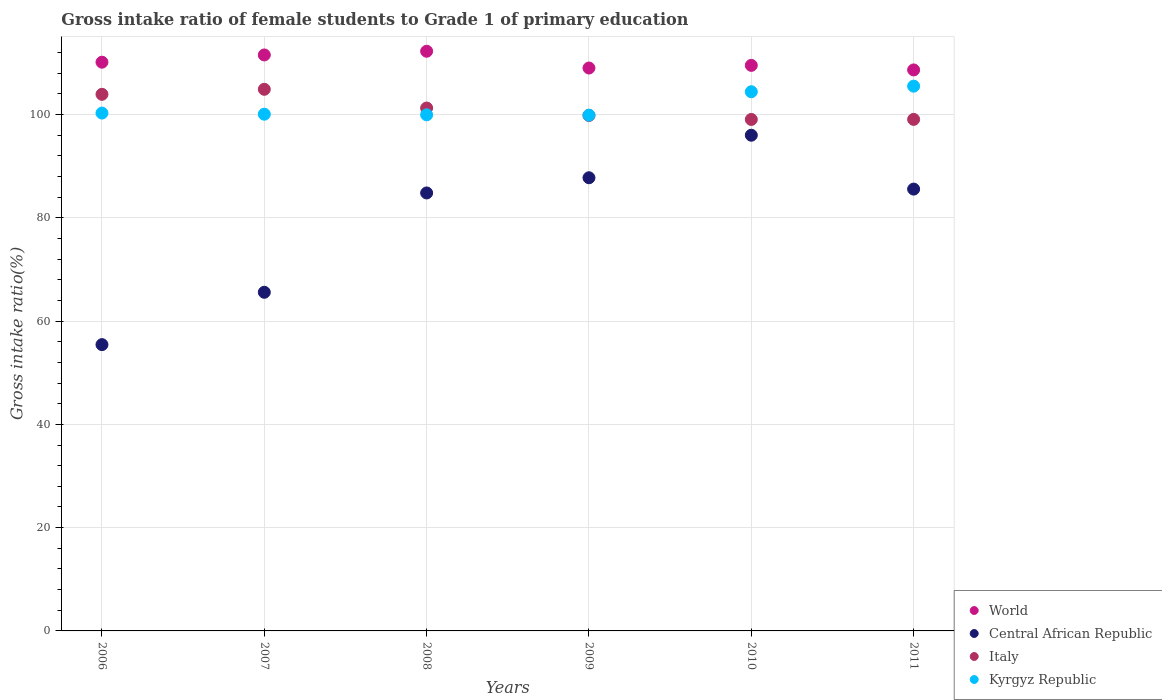How many different coloured dotlines are there?
Make the answer very short. 4. What is the gross intake ratio in Central African Republic in 2011?
Offer a terse response. 85.56. Across all years, what is the maximum gross intake ratio in World?
Provide a short and direct response. 112.26. Across all years, what is the minimum gross intake ratio in Italy?
Your answer should be compact. 99.05. In which year was the gross intake ratio in Central African Republic maximum?
Offer a very short reply. 2010. What is the total gross intake ratio in Italy in the graph?
Provide a succinct answer. 608. What is the difference between the gross intake ratio in Kyrgyz Republic in 2010 and that in 2011?
Keep it short and to the point. -1.08. What is the difference between the gross intake ratio in Central African Republic in 2006 and the gross intake ratio in World in 2010?
Offer a terse response. -54.08. What is the average gross intake ratio in World per year?
Your answer should be very brief. 110.18. In the year 2009, what is the difference between the gross intake ratio in Central African Republic and gross intake ratio in World?
Offer a very short reply. -21.25. What is the ratio of the gross intake ratio in Central African Republic in 2009 to that in 2010?
Offer a terse response. 0.91. Is the gross intake ratio in Central African Republic in 2007 less than that in 2009?
Give a very brief answer. Yes. Is the difference between the gross intake ratio in Central African Republic in 2006 and 2008 greater than the difference between the gross intake ratio in World in 2006 and 2008?
Make the answer very short. No. What is the difference between the highest and the second highest gross intake ratio in Kyrgyz Republic?
Make the answer very short. 1.08. What is the difference between the highest and the lowest gross intake ratio in Italy?
Make the answer very short. 5.84. Is it the case that in every year, the sum of the gross intake ratio in Italy and gross intake ratio in World  is greater than the sum of gross intake ratio in Kyrgyz Republic and gross intake ratio in Central African Republic?
Make the answer very short. No. Is it the case that in every year, the sum of the gross intake ratio in Kyrgyz Republic and gross intake ratio in Italy  is greater than the gross intake ratio in World?
Offer a terse response. Yes. Is the gross intake ratio in Kyrgyz Republic strictly greater than the gross intake ratio in World over the years?
Your answer should be very brief. No. How many dotlines are there?
Ensure brevity in your answer.  4. What is the difference between two consecutive major ticks on the Y-axis?
Your answer should be very brief. 20. Are the values on the major ticks of Y-axis written in scientific E-notation?
Offer a terse response. No. Does the graph contain any zero values?
Offer a terse response. No. Where does the legend appear in the graph?
Your answer should be compact. Bottom right. How are the legend labels stacked?
Your response must be concise. Vertical. What is the title of the graph?
Keep it short and to the point. Gross intake ratio of female students to Grade 1 of primary education. Does "Singapore" appear as one of the legend labels in the graph?
Ensure brevity in your answer.  No. What is the label or title of the X-axis?
Offer a terse response. Years. What is the label or title of the Y-axis?
Offer a very short reply. Gross intake ratio(%). What is the Gross intake ratio(%) of World in 2006?
Your answer should be compact. 110.14. What is the Gross intake ratio(%) of Central African Republic in 2006?
Make the answer very short. 55.44. What is the Gross intake ratio(%) in Italy in 2006?
Give a very brief answer. 103.92. What is the Gross intake ratio(%) of Kyrgyz Republic in 2006?
Provide a succinct answer. 100.28. What is the Gross intake ratio(%) in World in 2007?
Provide a short and direct response. 111.54. What is the Gross intake ratio(%) in Central African Republic in 2007?
Offer a terse response. 65.58. What is the Gross intake ratio(%) of Italy in 2007?
Your answer should be very brief. 104.89. What is the Gross intake ratio(%) of Kyrgyz Republic in 2007?
Offer a very short reply. 100.07. What is the Gross intake ratio(%) in World in 2008?
Provide a succinct answer. 112.26. What is the Gross intake ratio(%) of Central African Republic in 2008?
Provide a succinct answer. 84.81. What is the Gross intake ratio(%) of Italy in 2008?
Keep it short and to the point. 101.26. What is the Gross intake ratio(%) of Kyrgyz Republic in 2008?
Ensure brevity in your answer.  99.95. What is the Gross intake ratio(%) of World in 2009?
Keep it short and to the point. 109.01. What is the Gross intake ratio(%) of Central African Republic in 2009?
Offer a terse response. 87.76. What is the Gross intake ratio(%) of Italy in 2009?
Offer a terse response. 99.83. What is the Gross intake ratio(%) in Kyrgyz Republic in 2009?
Give a very brief answer. 99.88. What is the Gross intake ratio(%) of World in 2010?
Give a very brief answer. 109.52. What is the Gross intake ratio(%) in Central African Republic in 2010?
Keep it short and to the point. 95.99. What is the Gross intake ratio(%) of Italy in 2010?
Provide a short and direct response. 99.05. What is the Gross intake ratio(%) in Kyrgyz Republic in 2010?
Offer a terse response. 104.41. What is the Gross intake ratio(%) of World in 2011?
Make the answer very short. 108.64. What is the Gross intake ratio(%) in Central African Republic in 2011?
Offer a very short reply. 85.56. What is the Gross intake ratio(%) of Italy in 2011?
Provide a succinct answer. 99.06. What is the Gross intake ratio(%) in Kyrgyz Republic in 2011?
Your response must be concise. 105.5. Across all years, what is the maximum Gross intake ratio(%) in World?
Your answer should be very brief. 112.26. Across all years, what is the maximum Gross intake ratio(%) in Central African Republic?
Your answer should be compact. 95.99. Across all years, what is the maximum Gross intake ratio(%) of Italy?
Provide a short and direct response. 104.89. Across all years, what is the maximum Gross intake ratio(%) in Kyrgyz Republic?
Offer a very short reply. 105.5. Across all years, what is the minimum Gross intake ratio(%) in World?
Your response must be concise. 108.64. Across all years, what is the minimum Gross intake ratio(%) in Central African Republic?
Your answer should be very brief. 55.44. Across all years, what is the minimum Gross intake ratio(%) of Italy?
Make the answer very short. 99.05. Across all years, what is the minimum Gross intake ratio(%) of Kyrgyz Republic?
Provide a succinct answer. 99.88. What is the total Gross intake ratio(%) of World in the graph?
Your answer should be very brief. 661.1. What is the total Gross intake ratio(%) of Central African Republic in the graph?
Offer a very short reply. 475.15. What is the total Gross intake ratio(%) in Italy in the graph?
Offer a terse response. 608. What is the total Gross intake ratio(%) of Kyrgyz Republic in the graph?
Your answer should be very brief. 610.09. What is the difference between the Gross intake ratio(%) in World in 2006 and that in 2007?
Ensure brevity in your answer.  -1.4. What is the difference between the Gross intake ratio(%) of Central African Republic in 2006 and that in 2007?
Make the answer very short. -10.14. What is the difference between the Gross intake ratio(%) of Italy in 2006 and that in 2007?
Make the answer very short. -0.97. What is the difference between the Gross intake ratio(%) in Kyrgyz Republic in 2006 and that in 2007?
Your answer should be compact. 0.22. What is the difference between the Gross intake ratio(%) in World in 2006 and that in 2008?
Ensure brevity in your answer.  -2.12. What is the difference between the Gross intake ratio(%) of Central African Republic in 2006 and that in 2008?
Keep it short and to the point. -29.37. What is the difference between the Gross intake ratio(%) of Italy in 2006 and that in 2008?
Offer a very short reply. 2.65. What is the difference between the Gross intake ratio(%) of Kyrgyz Republic in 2006 and that in 2008?
Give a very brief answer. 0.34. What is the difference between the Gross intake ratio(%) in World in 2006 and that in 2009?
Offer a very short reply. 1.13. What is the difference between the Gross intake ratio(%) of Central African Republic in 2006 and that in 2009?
Your answer should be very brief. -32.31. What is the difference between the Gross intake ratio(%) of Italy in 2006 and that in 2009?
Your answer should be very brief. 4.09. What is the difference between the Gross intake ratio(%) in Kyrgyz Republic in 2006 and that in 2009?
Ensure brevity in your answer.  0.4. What is the difference between the Gross intake ratio(%) in World in 2006 and that in 2010?
Keep it short and to the point. 0.62. What is the difference between the Gross intake ratio(%) in Central African Republic in 2006 and that in 2010?
Offer a terse response. -40.55. What is the difference between the Gross intake ratio(%) in Italy in 2006 and that in 2010?
Your response must be concise. 4.87. What is the difference between the Gross intake ratio(%) in Kyrgyz Republic in 2006 and that in 2010?
Offer a very short reply. -4.13. What is the difference between the Gross intake ratio(%) in World in 2006 and that in 2011?
Offer a very short reply. 1.5. What is the difference between the Gross intake ratio(%) in Central African Republic in 2006 and that in 2011?
Your answer should be compact. -30.12. What is the difference between the Gross intake ratio(%) in Italy in 2006 and that in 2011?
Provide a succinct answer. 4.85. What is the difference between the Gross intake ratio(%) of Kyrgyz Republic in 2006 and that in 2011?
Ensure brevity in your answer.  -5.21. What is the difference between the Gross intake ratio(%) in World in 2007 and that in 2008?
Make the answer very short. -0.72. What is the difference between the Gross intake ratio(%) in Central African Republic in 2007 and that in 2008?
Give a very brief answer. -19.23. What is the difference between the Gross intake ratio(%) in Italy in 2007 and that in 2008?
Your answer should be compact. 3.63. What is the difference between the Gross intake ratio(%) of Kyrgyz Republic in 2007 and that in 2008?
Offer a very short reply. 0.12. What is the difference between the Gross intake ratio(%) of World in 2007 and that in 2009?
Provide a succinct answer. 2.53. What is the difference between the Gross intake ratio(%) of Central African Republic in 2007 and that in 2009?
Make the answer very short. -22.18. What is the difference between the Gross intake ratio(%) of Italy in 2007 and that in 2009?
Your answer should be compact. 5.06. What is the difference between the Gross intake ratio(%) of Kyrgyz Republic in 2007 and that in 2009?
Offer a terse response. 0.18. What is the difference between the Gross intake ratio(%) in World in 2007 and that in 2010?
Keep it short and to the point. 2.02. What is the difference between the Gross intake ratio(%) of Central African Republic in 2007 and that in 2010?
Ensure brevity in your answer.  -30.41. What is the difference between the Gross intake ratio(%) in Italy in 2007 and that in 2010?
Your answer should be very brief. 5.84. What is the difference between the Gross intake ratio(%) in Kyrgyz Republic in 2007 and that in 2010?
Give a very brief answer. -4.35. What is the difference between the Gross intake ratio(%) in World in 2007 and that in 2011?
Your response must be concise. 2.9. What is the difference between the Gross intake ratio(%) of Central African Republic in 2007 and that in 2011?
Your answer should be very brief. -19.98. What is the difference between the Gross intake ratio(%) of Italy in 2007 and that in 2011?
Ensure brevity in your answer.  5.83. What is the difference between the Gross intake ratio(%) of Kyrgyz Republic in 2007 and that in 2011?
Offer a very short reply. -5.43. What is the difference between the Gross intake ratio(%) of World in 2008 and that in 2009?
Keep it short and to the point. 3.25. What is the difference between the Gross intake ratio(%) in Central African Republic in 2008 and that in 2009?
Offer a very short reply. -2.94. What is the difference between the Gross intake ratio(%) of Italy in 2008 and that in 2009?
Keep it short and to the point. 1.44. What is the difference between the Gross intake ratio(%) in Kyrgyz Republic in 2008 and that in 2009?
Give a very brief answer. 0.07. What is the difference between the Gross intake ratio(%) of World in 2008 and that in 2010?
Ensure brevity in your answer.  2.74. What is the difference between the Gross intake ratio(%) in Central African Republic in 2008 and that in 2010?
Give a very brief answer. -11.18. What is the difference between the Gross intake ratio(%) of Italy in 2008 and that in 2010?
Provide a short and direct response. 2.21. What is the difference between the Gross intake ratio(%) in Kyrgyz Republic in 2008 and that in 2010?
Provide a short and direct response. -4.47. What is the difference between the Gross intake ratio(%) of World in 2008 and that in 2011?
Offer a very short reply. 3.62. What is the difference between the Gross intake ratio(%) in Central African Republic in 2008 and that in 2011?
Keep it short and to the point. -0.75. What is the difference between the Gross intake ratio(%) of Italy in 2008 and that in 2011?
Provide a succinct answer. 2.2. What is the difference between the Gross intake ratio(%) in Kyrgyz Republic in 2008 and that in 2011?
Provide a succinct answer. -5.55. What is the difference between the Gross intake ratio(%) in World in 2009 and that in 2010?
Provide a short and direct response. -0.51. What is the difference between the Gross intake ratio(%) in Central African Republic in 2009 and that in 2010?
Provide a succinct answer. -8.24. What is the difference between the Gross intake ratio(%) of Italy in 2009 and that in 2010?
Give a very brief answer. 0.78. What is the difference between the Gross intake ratio(%) in Kyrgyz Republic in 2009 and that in 2010?
Ensure brevity in your answer.  -4.53. What is the difference between the Gross intake ratio(%) in World in 2009 and that in 2011?
Offer a terse response. 0.37. What is the difference between the Gross intake ratio(%) of Central African Republic in 2009 and that in 2011?
Provide a succinct answer. 2.2. What is the difference between the Gross intake ratio(%) of Italy in 2009 and that in 2011?
Offer a very short reply. 0.77. What is the difference between the Gross intake ratio(%) of Kyrgyz Republic in 2009 and that in 2011?
Give a very brief answer. -5.62. What is the difference between the Gross intake ratio(%) in World in 2010 and that in 2011?
Offer a terse response. 0.88. What is the difference between the Gross intake ratio(%) in Central African Republic in 2010 and that in 2011?
Your response must be concise. 10.43. What is the difference between the Gross intake ratio(%) of Italy in 2010 and that in 2011?
Make the answer very short. -0.01. What is the difference between the Gross intake ratio(%) in Kyrgyz Republic in 2010 and that in 2011?
Ensure brevity in your answer.  -1.08. What is the difference between the Gross intake ratio(%) in World in 2006 and the Gross intake ratio(%) in Central African Republic in 2007?
Provide a succinct answer. 44.56. What is the difference between the Gross intake ratio(%) of World in 2006 and the Gross intake ratio(%) of Italy in 2007?
Your response must be concise. 5.25. What is the difference between the Gross intake ratio(%) of World in 2006 and the Gross intake ratio(%) of Kyrgyz Republic in 2007?
Keep it short and to the point. 10.07. What is the difference between the Gross intake ratio(%) of Central African Republic in 2006 and the Gross intake ratio(%) of Italy in 2007?
Offer a terse response. -49.45. What is the difference between the Gross intake ratio(%) of Central African Republic in 2006 and the Gross intake ratio(%) of Kyrgyz Republic in 2007?
Provide a succinct answer. -44.62. What is the difference between the Gross intake ratio(%) of Italy in 2006 and the Gross intake ratio(%) of Kyrgyz Republic in 2007?
Make the answer very short. 3.85. What is the difference between the Gross intake ratio(%) of World in 2006 and the Gross intake ratio(%) of Central African Republic in 2008?
Provide a succinct answer. 25.32. What is the difference between the Gross intake ratio(%) in World in 2006 and the Gross intake ratio(%) in Italy in 2008?
Your answer should be very brief. 8.87. What is the difference between the Gross intake ratio(%) in World in 2006 and the Gross intake ratio(%) in Kyrgyz Republic in 2008?
Your answer should be compact. 10.19. What is the difference between the Gross intake ratio(%) of Central African Republic in 2006 and the Gross intake ratio(%) of Italy in 2008?
Ensure brevity in your answer.  -45.82. What is the difference between the Gross intake ratio(%) of Central African Republic in 2006 and the Gross intake ratio(%) of Kyrgyz Republic in 2008?
Your answer should be very brief. -44.51. What is the difference between the Gross intake ratio(%) of Italy in 2006 and the Gross intake ratio(%) of Kyrgyz Republic in 2008?
Your response must be concise. 3.97. What is the difference between the Gross intake ratio(%) in World in 2006 and the Gross intake ratio(%) in Central African Republic in 2009?
Your answer should be compact. 22.38. What is the difference between the Gross intake ratio(%) in World in 2006 and the Gross intake ratio(%) in Italy in 2009?
Your answer should be very brief. 10.31. What is the difference between the Gross intake ratio(%) of World in 2006 and the Gross intake ratio(%) of Kyrgyz Republic in 2009?
Ensure brevity in your answer.  10.25. What is the difference between the Gross intake ratio(%) in Central African Republic in 2006 and the Gross intake ratio(%) in Italy in 2009?
Keep it short and to the point. -44.38. What is the difference between the Gross intake ratio(%) of Central African Republic in 2006 and the Gross intake ratio(%) of Kyrgyz Republic in 2009?
Your answer should be very brief. -44.44. What is the difference between the Gross intake ratio(%) in Italy in 2006 and the Gross intake ratio(%) in Kyrgyz Republic in 2009?
Provide a short and direct response. 4.03. What is the difference between the Gross intake ratio(%) of World in 2006 and the Gross intake ratio(%) of Central African Republic in 2010?
Offer a terse response. 14.14. What is the difference between the Gross intake ratio(%) in World in 2006 and the Gross intake ratio(%) in Italy in 2010?
Give a very brief answer. 11.09. What is the difference between the Gross intake ratio(%) in World in 2006 and the Gross intake ratio(%) in Kyrgyz Republic in 2010?
Offer a very short reply. 5.72. What is the difference between the Gross intake ratio(%) of Central African Republic in 2006 and the Gross intake ratio(%) of Italy in 2010?
Provide a succinct answer. -43.61. What is the difference between the Gross intake ratio(%) in Central African Republic in 2006 and the Gross intake ratio(%) in Kyrgyz Republic in 2010?
Offer a terse response. -48.97. What is the difference between the Gross intake ratio(%) of Italy in 2006 and the Gross intake ratio(%) of Kyrgyz Republic in 2010?
Keep it short and to the point. -0.5. What is the difference between the Gross intake ratio(%) in World in 2006 and the Gross intake ratio(%) in Central African Republic in 2011?
Your answer should be compact. 24.58. What is the difference between the Gross intake ratio(%) of World in 2006 and the Gross intake ratio(%) of Italy in 2011?
Your answer should be very brief. 11.08. What is the difference between the Gross intake ratio(%) of World in 2006 and the Gross intake ratio(%) of Kyrgyz Republic in 2011?
Offer a very short reply. 4.64. What is the difference between the Gross intake ratio(%) of Central African Republic in 2006 and the Gross intake ratio(%) of Italy in 2011?
Keep it short and to the point. -43.62. What is the difference between the Gross intake ratio(%) in Central African Republic in 2006 and the Gross intake ratio(%) in Kyrgyz Republic in 2011?
Ensure brevity in your answer.  -50.06. What is the difference between the Gross intake ratio(%) of Italy in 2006 and the Gross intake ratio(%) of Kyrgyz Republic in 2011?
Give a very brief answer. -1.58. What is the difference between the Gross intake ratio(%) of World in 2007 and the Gross intake ratio(%) of Central African Republic in 2008?
Your answer should be very brief. 26.73. What is the difference between the Gross intake ratio(%) in World in 2007 and the Gross intake ratio(%) in Italy in 2008?
Make the answer very short. 10.28. What is the difference between the Gross intake ratio(%) of World in 2007 and the Gross intake ratio(%) of Kyrgyz Republic in 2008?
Keep it short and to the point. 11.59. What is the difference between the Gross intake ratio(%) in Central African Republic in 2007 and the Gross intake ratio(%) in Italy in 2008?
Offer a terse response. -35.68. What is the difference between the Gross intake ratio(%) of Central African Republic in 2007 and the Gross intake ratio(%) of Kyrgyz Republic in 2008?
Give a very brief answer. -34.37. What is the difference between the Gross intake ratio(%) in Italy in 2007 and the Gross intake ratio(%) in Kyrgyz Republic in 2008?
Ensure brevity in your answer.  4.94. What is the difference between the Gross intake ratio(%) of World in 2007 and the Gross intake ratio(%) of Central African Republic in 2009?
Provide a short and direct response. 23.78. What is the difference between the Gross intake ratio(%) in World in 2007 and the Gross intake ratio(%) in Italy in 2009?
Your response must be concise. 11.71. What is the difference between the Gross intake ratio(%) in World in 2007 and the Gross intake ratio(%) in Kyrgyz Republic in 2009?
Ensure brevity in your answer.  11.66. What is the difference between the Gross intake ratio(%) in Central African Republic in 2007 and the Gross intake ratio(%) in Italy in 2009?
Provide a succinct answer. -34.25. What is the difference between the Gross intake ratio(%) of Central African Republic in 2007 and the Gross intake ratio(%) of Kyrgyz Republic in 2009?
Keep it short and to the point. -34.3. What is the difference between the Gross intake ratio(%) in Italy in 2007 and the Gross intake ratio(%) in Kyrgyz Republic in 2009?
Your answer should be compact. 5.01. What is the difference between the Gross intake ratio(%) of World in 2007 and the Gross intake ratio(%) of Central African Republic in 2010?
Give a very brief answer. 15.55. What is the difference between the Gross intake ratio(%) of World in 2007 and the Gross intake ratio(%) of Italy in 2010?
Give a very brief answer. 12.49. What is the difference between the Gross intake ratio(%) of World in 2007 and the Gross intake ratio(%) of Kyrgyz Republic in 2010?
Provide a succinct answer. 7.13. What is the difference between the Gross intake ratio(%) of Central African Republic in 2007 and the Gross intake ratio(%) of Italy in 2010?
Keep it short and to the point. -33.47. What is the difference between the Gross intake ratio(%) in Central African Republic in 2007 and the Gross intake ratio(%) in Kyrgyz Republic in 2010?
Your answer should be very brief. -38.83. What is the difference between the Gross intake ratio(%) in Italy in 2007 and the Gross intake ratio(%) in Kyrgyz Republic in 2010?
Your response must be concise. 0.47. What is the difference between the Gross intake ratio(%) of World in 2007 and the Gross intake ratio(%) of Central African Republic in 2011?
Keep it short and to the point. 25.98. What is the difference between the Gross intake ratio(%) of World in 2007 and the Gross intake ratio(%) of Italy in 2011?
Offer a very short reply. 12.48. What is the difference between the Gross intake ratio(%) in World in 2007 and the Gross intake ratio(%) in Kyrgyz Republic in 2011?
Offer a terse response. 6.04. What is the difference between the Gross intake ratio(%) of Central African Republic in 2007 and the Gross intake ratio(%) of Italy in 2011?
Provide a short and direct response. -33.48. What is the difference between the Gross intake ratio(%) of Central African Republic in 2007 and the Gross intake ratio(%) of Kyrgyz Republic in 2011?
Make the answer very short. -39.92. What is the difference between the Gross intake ratio(%) of Italy in 2007 and the Gross intake ratio(%) of Kyrgyz Republic in 2011?
Offer a terse response. -0.61. What is the difference between the Gross intake ratio(%) of World in 2008 and the Gross intake ratio(%) of Central African Republic in 2009?
Your answer should be very brief. 24.5. What is the difference between the Gross intake ratio(%) of World in 2008 and the Gross intake ratio(%) of Italy in 2009?
Keep it short and to the point. 12.43. What is the difference between the Gross intake ratio(%) in World in 2008 and the Gross intake ratio(%) in Kyrgyz Republic in 2009?
Provide a short and direct response. 12.37. What is the difference between the Gross intake ratio(%) of Central African Republic in 2008 and the Gross intake ratio(%) of Italy in 2009?
Give a very brief answer. -15.01. What is the difference between the Gross intake ratio(%) of Central African Republic in 2008 and the Gross intake ratio(%) of Kyrgyz Republic in 2009?
Provide a short and direct response. -15.07. What is the difference between the Gross intake ratio(%) in Italy in 2008 and the Gross intake ratio(%) in Kyrgyz Republic in 2009?
Your response must be concise. 1.38. What is the difference between the Gross intake ratio(%) in World in 2008 and the Gross intake ratio(%) in Central African Republic in 2010?
Your response must be concise. 16.26. What is the difference between the Gross intake ratio(%) in World in 2008 and the Gross intake ratio(%) in Italy in 2010?
Ensure brevity in your answer.  13.21. What is the difference between the Gross intake ratio(%) of World in 2008 and the Gross intake ratio(%) of Kyrgyz Republic in 2010?
Your response must be concise. 7.84. What is the difference between the Gross intake ratio(%) in Central African Republic in 2008 and the Gross intake ratio(%) in Italy in 2010?
Ensure brevity in your answer.  -14.24. What is the difference between the Gross intake ratio(%) in Central African Republic in 2008 and the Gross intake ratio(%) in Kyrgyz Republic in 2010?
Offer a very short reply. -19.6. What is the difference between the Gross intake ratio(%) in Italy in 2008 and the Gross intake ratio(%) in Kyrgyz Republic in 2010?
Provide a short and direct response. -3.15. What is the difference between the Gross intake ratio(%) of World in 2008 and the Gross intake ratio(%) of Central African Republic in 2011?
Give a very brief answer. 26.7. What is the difference between the Gross intake ratio(%) in World in 2008 and the Gross intake ratio(%) in Italy in 2011?
Offer a terse response. 13.2. What is the difference between the Gross intake ratio(%) in World in 2008 and the Gross intake ratio(%) in Kyrgyz Republic in 2011?
Your answer should be very brief. 6.76. What is the difference between the Gross intake ratio(%) in Central African Republic in 2008 and the Gross intake ratio(%) in Italy in 2011?
Offer a terse response. -14.25. What is the difference between the Gross intake ratio(%) in Central African Republic in 2008 and the Gross intake ratio(%) in Kyrgyz Republic in 2011?
Your answer should be very brief. -20.68. What is the difference between the Gross intake ratio(%) in Italy in 2008 and the Gross intake ratio(%) in Kyrgyz Republic in 2011?
Ensure brevity in your answer.  -4.24. What is the difference between the Gross intake ratio(%) of World in 2009 and the Gross intake ratio(%) of Central African Republic in 2010?
Your answer should be very brief. 13.01. What is the difference between the Gross intake ratio(%) in World in 2009 and the Gross intake ratio(%) in Italy in 2010?
Make the answer very short. 9.96. What is the difference between the Gross intake ratio(%) of World in 2009 and the Gross intake ratio(%) of Kyrgyz Republic in 2010?
Make the answer very short. 4.59. What is the difference between the Gross intake ratio(%) in Central African Republic in 2009 and the Gross intake ratio(%) in Italy in 2010?
Keep it short and to the point. -11.29. What is the difference between the Gross intake ratio(%) in Central African Republic in 2009 and the Gross intake ratio(%) in Kyrgyz Republic in 2010?
Provide a succinct answer. -16.66. What is the difference between the Gross intake ratio(%) in Italy in 2009 and the Gross intake ratio(%) in Kyrgyz Republic in 2010?
Keep it short and to the point. -4.59. What is the difference between the Gross intake ratio(%) in World in 2009 and the Gross intake ratio(%) in Central African Republic in 2011?
Your response must be concise. 23.45. What is the difference between the Gross intake ratio(%) of World in 2009 and the Gross intake ratio(%) of Italy in 2011?
Keep it short and to the point. 9.95. What is the difference between the Gross intake ratio(%) of World in 2009 and the Gross intake ratio(%) of Kyrgyz Republic in 2011?
Keep it short and to the point. 3.51. What is the difference between the Gross intake ratio(%) of Central African Republic in 2009 and the Gross intake ratio(%) of Italy in 2011?
Your answer should be very brief. -11.3. What is the difference between the Gross intake ratio(%) in Central African Republic in 2009 and the Gross intake ratio(%) in Kyrgyz Republic in 2011?
Provide a short and direct response. -17.74. What is the difference between the Gross intake ratio(%) in Italy in 2009 and the Gross intake ratio(%) in Kyrgyz Republic in 2011?
Provide a short and direct response. -5.67. What is the difference between the Gross intake ratio(%) in World in 2010 and the Gross intake ratio(%) in Central African Republic in 2011?
Offer a terse response. 23.96. What is the difference between the Gross intake ratio(%) of World in 2010 and the Gross intake ratio(%) of Italy in 2011?
Make the answer very short. 10.46. What is the difference between the Gross intake ratio(%) of World in 2010 and the Gross intake ratio(%) of Kyrgyz Republic in 2011?
Your answer should be very brief. 4.02. What is the difference between the Gross intake ratio(%) in Central African Republic in 2010 and the Gross intake ratio(%) in Italy in 2011?
Provide a succinct answer. -3.07. What is the difference between the Gross intake ratio(%) in Central African Republic in 2010 and the Gross intake ratio(%) in Kyrgyz Republic in 2011?
Make the answer very short. -9.5. What is the difference between the Gross intake ratio(%) of Italy in 2010 and the Gross intake ratio(%) of Kyrgyz Republic in 2011?
Provide a succinct answer. -6.45. What is the average Gross intake ratio(%) in World per year?
Offer a terse response. 110.18. What is the average Gross intake ratio(%) in Central African Republic per year?
Keep it short and to the point. 79.19. What is the average Gross intake ratio(%) of Italy per year?
Provide a short and direct response. 101.33. What is the average Gross intake ratio(%) in Kyrgyz Republic per year?
Offer a terse response. 101.68. In the year 2006, what is the difference between the Gross intake ratio(%) of World and Gross intake ratio(%) of Central African Republic?
Your response must be concise. 54.69. In the year 2006, what is the difference between the Gross intake ratio(%) of World and Gross intake ratio(%) of Italy?
Keep it short and to the point. 6.22. In the year 2006, what is the difference between the Gross intake ratio(%) of World and Gross intake ratio(%) of Kyrgyz Republic?
Offer a terse response. 9.85. In the year 2006, what is the difference between the Gross intake ratio(%) of Central African Republic and Gross intake ratio(%) of Italy?
Provide a succinct answer. -48.47. In the year 2006, what is the difference between the Gross intake ratio(%) of Central African Republic and Gross intake ratio(%) of Kyrgyz Republic?
Keep it short and to the point. -44.84. In the year 2006, what is the difference between the Gross intake ratio(%) in Italy and Gross intake ratio(%) in Kyrgyz Republic?
Provide a succinct answer. 3.63. In the year 2007, what is the difference between the Gross intake ratio(%) in World and Gross intake ratio(%) in Central African Republic?
Ensure brevity in your answer.  45.96. In the year 2007, what is the difference between the Gross intake ratio(%) of World and Gross intake ratio(%) of Italy?
Make the answer very short. 6.65. In the year 2007, what is the difference between the Gross intake ratio(%) in World and Gross intake ratio(%) in Kyrgyz Republic?
Your response must be concise. 11.48. In the year 2007, what is the difference between the Gross intake ratio(%) in Central African Republic and Gross intake ratio(%) in Italy?
Your answer should be very brief. -39.31. In the year 2007, what is the difference between the Gross intake ratio(%) of Central African Republic and Gross intake ratio(%) of Kyrgyz Republic?
Ensure brevity in your answer.  -34.49. In the year 2007, what is the difference between the Gross intake ratio(%) in Italy and Gross intake ratio(%) in Kyrgyz Republic?
Offer a terse response. 4.82. In the year 2008, what is the difference between the Gross intake ratio(%) in World and Gross intake ratio(%) in Central African Republic?
Offer a very short reply. 27.44. In the year 2008, what is the difference between the Gross intake ratio(%) in World and Gross intake ratio(%) in Italy?
Ensure brevity in your answer.  10.99. In the year 2008, what is the difference between the Gross intake ratio(%) of World and Gross intake ratio(%) of Kyrgyz Republic?
Offer a very short reply. 12.31. In the year 2008, what is the difference between the Gross intake ratio(%) of Central African Republic and Gross intake ratio(%) of Italy?
Give a very brief answer. -16.45. In the year 2008, what is the difference between the Gross intake ratio(%) of Central African Republic and Gross intake ratio(%) of Kyrgyz Republic?
Your answer should be compact. -15.13. In the year 2008, what is the difference between the Gross intake ratio(%) in Italy and Gross intake ratio(%) in Kyrgyz Republic?
Ensure brevity in your answer.  1.31. In the year 2009, what is the difference between the Gross intake ratio(%) in World and Gross intake ratio(%) in Central African Republic?
Your answer should be compact. 21.25. In the year 2009, what is the difference between the Gross intake ratio(%) of World and Gross intake ratio(%) of Italy?
Your answer should be compact. 9.18. In the year 2009, what is the difference between the Gross intake ratio(%) in World and Gross intake ratio(%) in Kyrgyz Republic?
Offer a very short reply. 9.13. In the year 2009, what is the difference between the Gross intake ratio(%) of Central African Republic and Gross intake ratio(%) of Italy?
Give a very brief answer. -12.07. In the year 2009, what is the difference between the Gross intake ratio(%) of Central African Republic and Gross intake ratio(%) of Kyrgyz Republic?
Keep it short and to the point. -12.13. In the year 2009, what is the difference between the Gross intake ratio(%) in Italy and Gross intake ratio(%) in Kyrgyz Republic?
Keep it short and to the point. -0.06. In the year 2010, what is the difference between the Gross intake ratio(%) of World and Gross intake ratio(%) of Central African Republic?
Your answer should be compact. 13.53. In the year 2010, what is the difference between the Gross intake ratio(%) in World and Gross intake ratio(%) in Italy?
Your answer should be very brief. 10.47. In the year 2010, what is the difference between the Gross intake ratio(%) in World and Gross intake ratio(%) in Kyrgyz Republic?
Offer a very short reply. 5.11. In the year 2010, what is the difference between the Gross intake ratio(%) of Central African Republic and Gross intake ratio(%) of Italy?
Provide a short and direct response. -3.06. In the year 2010, what is the difference between the Gross intake ratio(%) of Central African Republic and Gross intake ratio(%) of Kyrgyz Republic?
Keep it short and to the point. -8.42. In the year 2010, what is the difference between the Gross intake ratio(%) in Italy and Gross intake ratio(%) in Kyrgyz Republic?
Provide a succinct answer. -5.37. In the year 2011, what is the difference between the Gross intake ratio(%) in World and Gross intake ratio(%) in Central African Republic?
Make the answer very short. 23.08. In the year 2011, what is the difference between the Gross intake ratio(%) of World and Gross intake ratio(%) of Italy?
Offer a very short reply. 9.58. In the year 2011, what is the difference between the Gross intake ratio(%) of World and Gross intake ratio(%) of Kyrgyz Republic?
Your response must be concise. 3.14. In the year 2011, what is the difference between the Gross intake ratio(%) in Central African Republic and Gross intake ratio(%) in Italy?
Provide a succinct answer. -13.5. In the year 2011, what is the difference between the Gross intake ratio(%) of Central African Republic and Gross intake ratio(%) of Kyrgyz Republic?
Ensure brevity in your answer.  -19.94. In the year 2011, what is the difference between the Gross intake ratio(%) of Italy and Gross intake ratio(%) of Kyrgyz Republic?
Keep it short and to the point. -6.44. What is the ratio of the Gross intake ratio(%) in World in 2006 to that in 2007?
Your response must be concise. 0.99. What is the ratio of the Gross intake ratio(%) of Central African Republic in 2006 to that in 2007?
Your answer should be very brief. 0.85. What is the ratio of the Gross intake ratio(%) of World in 2006 to that in 2008?
Your answer should be compact. 0.98. What is the ratio of the Gross intake ratio(%) of Central African Republic in 2006 to that in 2008?
Your response must be concise. 0.65. What is the ratio of the Gross intake ratio(%) of Italy in 2006 to that in 2008?
Keep it short and to the point. 1.03. What is the ratio of the Gross intake ratio(%) of Kyrgyz Republic in 2006 to that in 2008?
Keep it short and to the point. 1. What is the ratio of the Gross intake ratio(%) in World in 2006 to that in 2009?
Your answer should be very brief. 1.01. What is the ratio of the Gross intake ratio(%) in Central African Republic in 2006 to that in 2009?
Provide a short and direct response. 0.63. What is the ratio of the Gross intake ratio(%) in Italy in 2006 to that in 2009?
Your answer should be compact. 1.04. What is the ratio of the Gross intake ratio(%) in World in 2006 to that in 2010?
Ensure brevity in your answer.  1.01. What is the ratio of the Gross intake ratio(%) of Central African Republic in 2006 to that in 2010?
Keep it short and to the point. 0.58. What is the ratio of the Gross intake ratio(%) of Italy in 2006 to that in 2010?
Provide a short and direct response. 1.05. What is the ratio of the Gross intake ratio(%) in Kyrgyz Republic in 2006 to that in 2010?
Provide a succinct answer. 0.96. What is the ratio of the Gross intake ratio(%) of World in 2006 to that in 2011?
Keep it short and to the point. 1.01. What is the ratio of the Gross intake ratio(%) of Central African Republic in 2006 to that in 2011?
Provide a short and direct response. 0.65. What is the ratio of the Gross intake ratio(%) in Italy in 2006 to that in 2011?
Keep it short and to the point. 1.05. What is the ratio of the Gross intake ratio(%) of Kyrgyz Republic in 2006 to that in 2011?
Offer a very short reply. 0.95. What is the ratio of the Gross intake ratio(%) of World in 2007 to that in 2008?
Offer a terse response. 0.99. What is the ratio of the Gross intake ratio(%) of Central African Republic in 2007 to that in 2008?
Provide a short and direct response. 0.77. What is the ratio of the Gross intake ratio(%) of Italy in 2007 to that in 2008?
Provide a succinct answer. 1.04. What is the ratio of the Gross intake ratio(%) of World in 2007 to that in 2009?
Your answer should be very brief. 1.02. What is the ratio of the Gross intake ratio(%) of Central African Republic in 2007 to that in 2009?
Your answer should be very brief. 0.75. What is the ratio of the Gross intake ratio(%) in Italy in 2007 to that in 2009?
Your answer should be very brief. 1.05. What is the ratio of the Gross intake ratio(%) in World in 2007 to that in 2010?
Give a very brief answer. 1.02. What is the ratio of the Gross intake ratio(%) in Central African Republic in 2007 to that in 2010?
Your answer should be compact. 0.68. What is the ratio of the Gross intake ratio(%) in Italy in 2007 to that in 2010?
Give a very brief answer. 1.06. What is the ratio of the Gross intake ratio(%) in World in 2007 to that in 2011?
Provide a succinct answer. 1.03. What is the ratio of the Gross intake ratio(%) of Central African Republic in 2007 to that in 2011?
Your answer should be compact. 0.77. What is the ratio of the Gross intake ratio(%) of Italy in 2007 to that in 2011?
Offer a terse response. 1.06. What is the ratio of the Gross intake ratio(%) in Kyrgyz Republic in 2007 to that in 2011?
Your answer should be compact. 0.95. What is the ratio of the Gross intake ratio(%) in World in 2008 to that in 2009?
Offer a terse response. 1.03. What is the ratio of the Gross intake ratio(%) in Central African Republic in 2008 to that in 2009?
Keep it short and to the point. 0.97. What is the ratio of the Gross intake ratio(%) of Italy in 2008 to that in 2009?
Offer a terse response. 1.01. What is the ratio of the Gross intake ratio(%) of Kyrgyz Republic in 2008 to that in 2009?
Give a very brief answer. 1. What is the ratio of the Gross intake ratio(%) of Central African Republic in 2008 to that in 2010?
Make the answer very short. 0.88. What is the ratio of the Gross intake ratio(%) in Italy in 2008 to that in 2010?
Offer a very short reply. 1.02. What is the ratio of the Gross intake ratio(%) in Kyrgyz Republic in 2008 to that in 2010?
Give a very brief answer. 0.96. What is the ratio of the Gross intake ratio(%) in Central African Republic in 2008 to that in 2011?
Offer a very short reply. 0.99. What is the ratio of the Gross intake ratio(%) of Italy in 2008 to that in 2011?
Offer a very short reply. 1.02. What is the ratio of the Gross intake ratio(%) of Kyrgyz Republic in 2008 to that in 2011?
Make the answer very short. 0.95. What is the ratio of the Gross intake ratio(%) in Central African Republic in 2009 to that in 2010?
Your answer should be compact. 0.91. What is the ratio of the Gross intake ratio(%) of Kyrgyz Republic in 2009 to that in 2010?
Offer a very short reply. 0.96. What is the ratio of the Gross intake ratio(%) of Central African Republic in 2009 to that in 2011?
Provide a short and direct response. 1.03. What is the ratio of the Gross intake ratio(%) of Italy in 2009 to that in 2011?
Make the answer very short. 1.01. What is the ratio of the Gross intake ratio(%) in Kyrgyz Republic in 2009 to that in 2011?
Ensure brevity in your answer.  0.95. What is the ratio of the Gross intake ratio(%) of World in 2010 to that in 2011?
Give a very brief answer. 1.01. What is the ratio of the Gross intake ratio(%) of Central African Republic in 2010 to that in 2011?
Your answer should be very brief. 1.12. What is the ratio of the Gross intake ratio(%) in Kyrgyz Republic in 2010 to that in 2011?
Ensure brevity in your answer.  0.99. What is the difference between the highest and the second highest Gross intake ratio(%) of World?
Your response must be concise. 0.72. What is the difference between the highest and the second highest Gross intake ratio(%) in Central African Republic?
Ensure brevity in your answer.  8.24. What is the difference between the highest and the second highest Gross intake ratio(%) in Italy?
Offer a terse response. 0.97. What is the difference between the highest and the second highest Gross intake ratio(%) of Kyrgyz Republic?
Offer a terse response. 1.08. What is the difference between the highest and the lowest Gross intake ratio(%) of World?
Your answer should be very brief. 3.62. What is the difference between the highest and the lowest Gross intake ratio(%) of Central African Republic?
Your answer should be very brief. 40.55. What is the difference between the highest and the lowest Gross intake ratio(%) of Italy?
Your answer should be compact. 5.84. What is the difference between the highest and the lowest Gross intake ratio(%) in Kyrgyz Republic?
Make the answer very short. 5.62. 